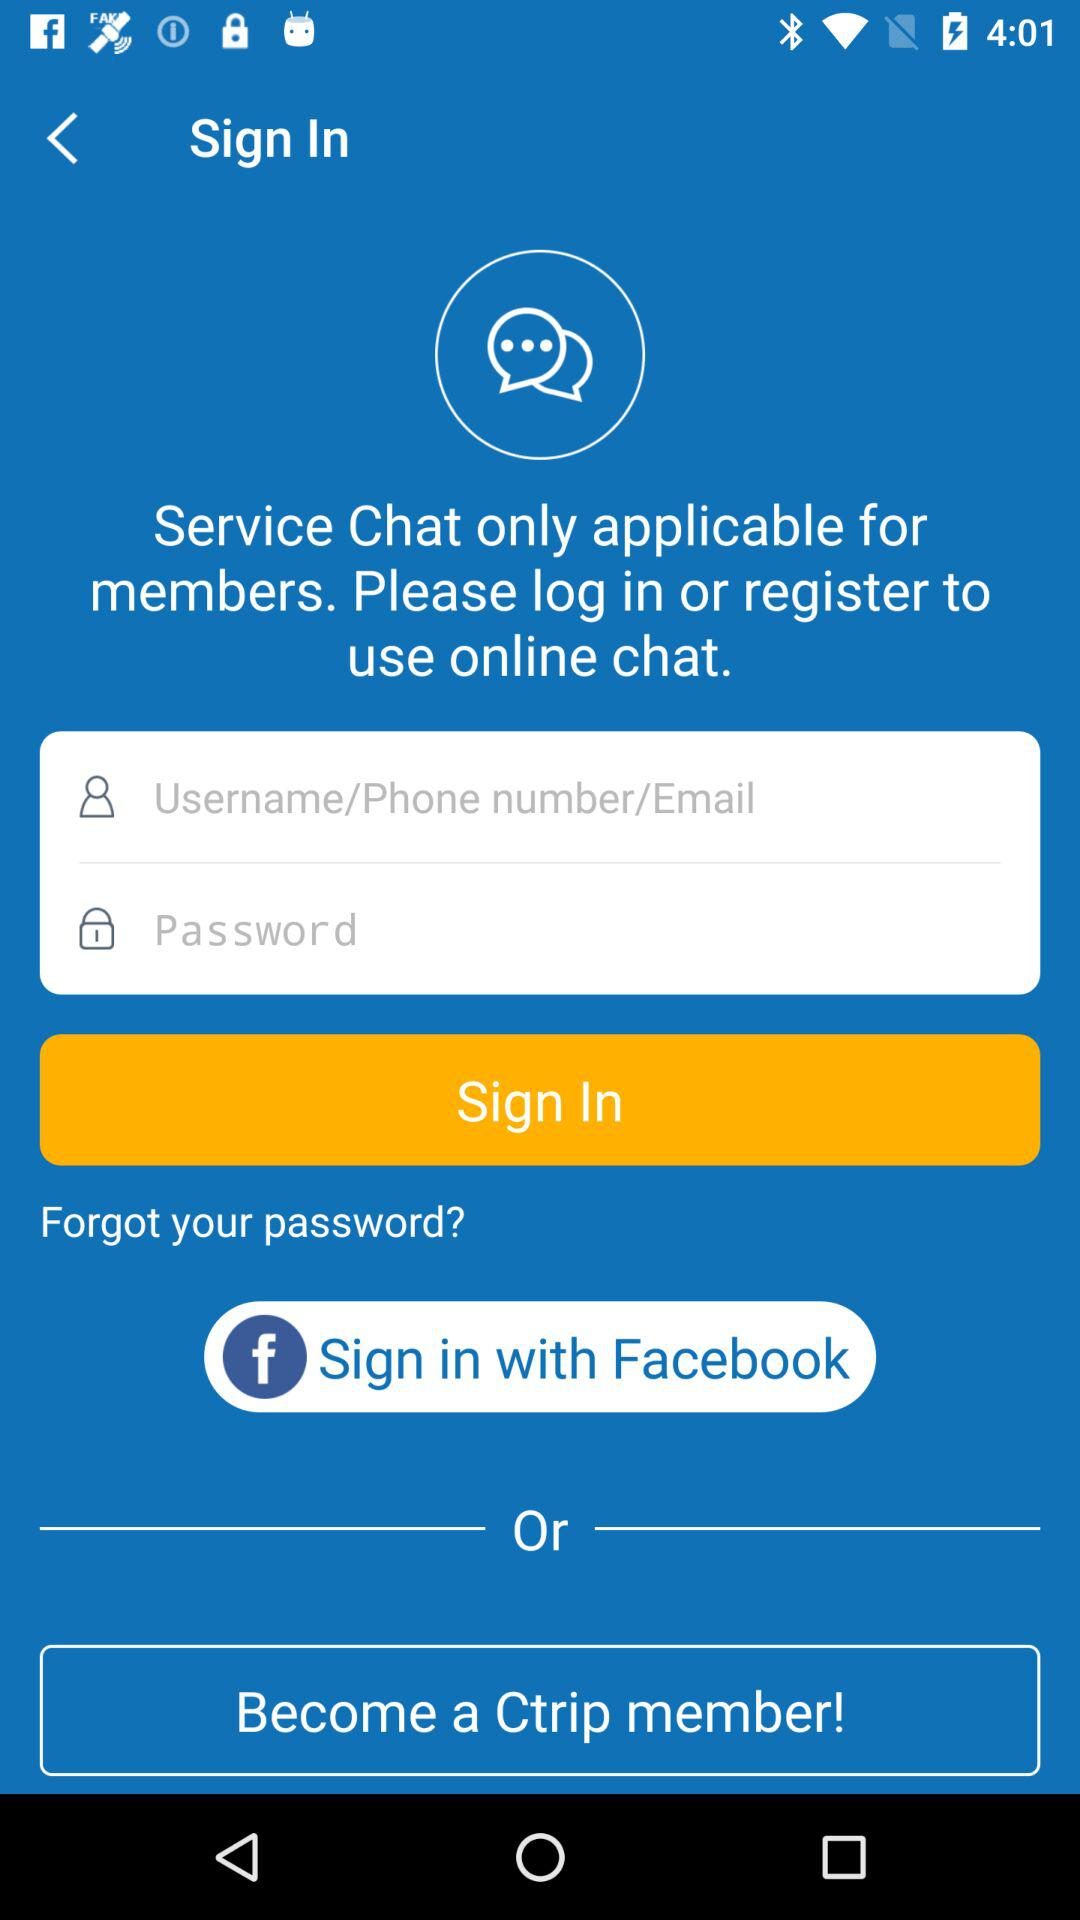What social app can we use to sign in? You can use "Facebook" to sign in. 